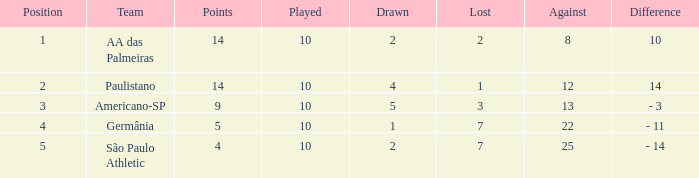What is the sum of Against when the lost is more than 7? None. 